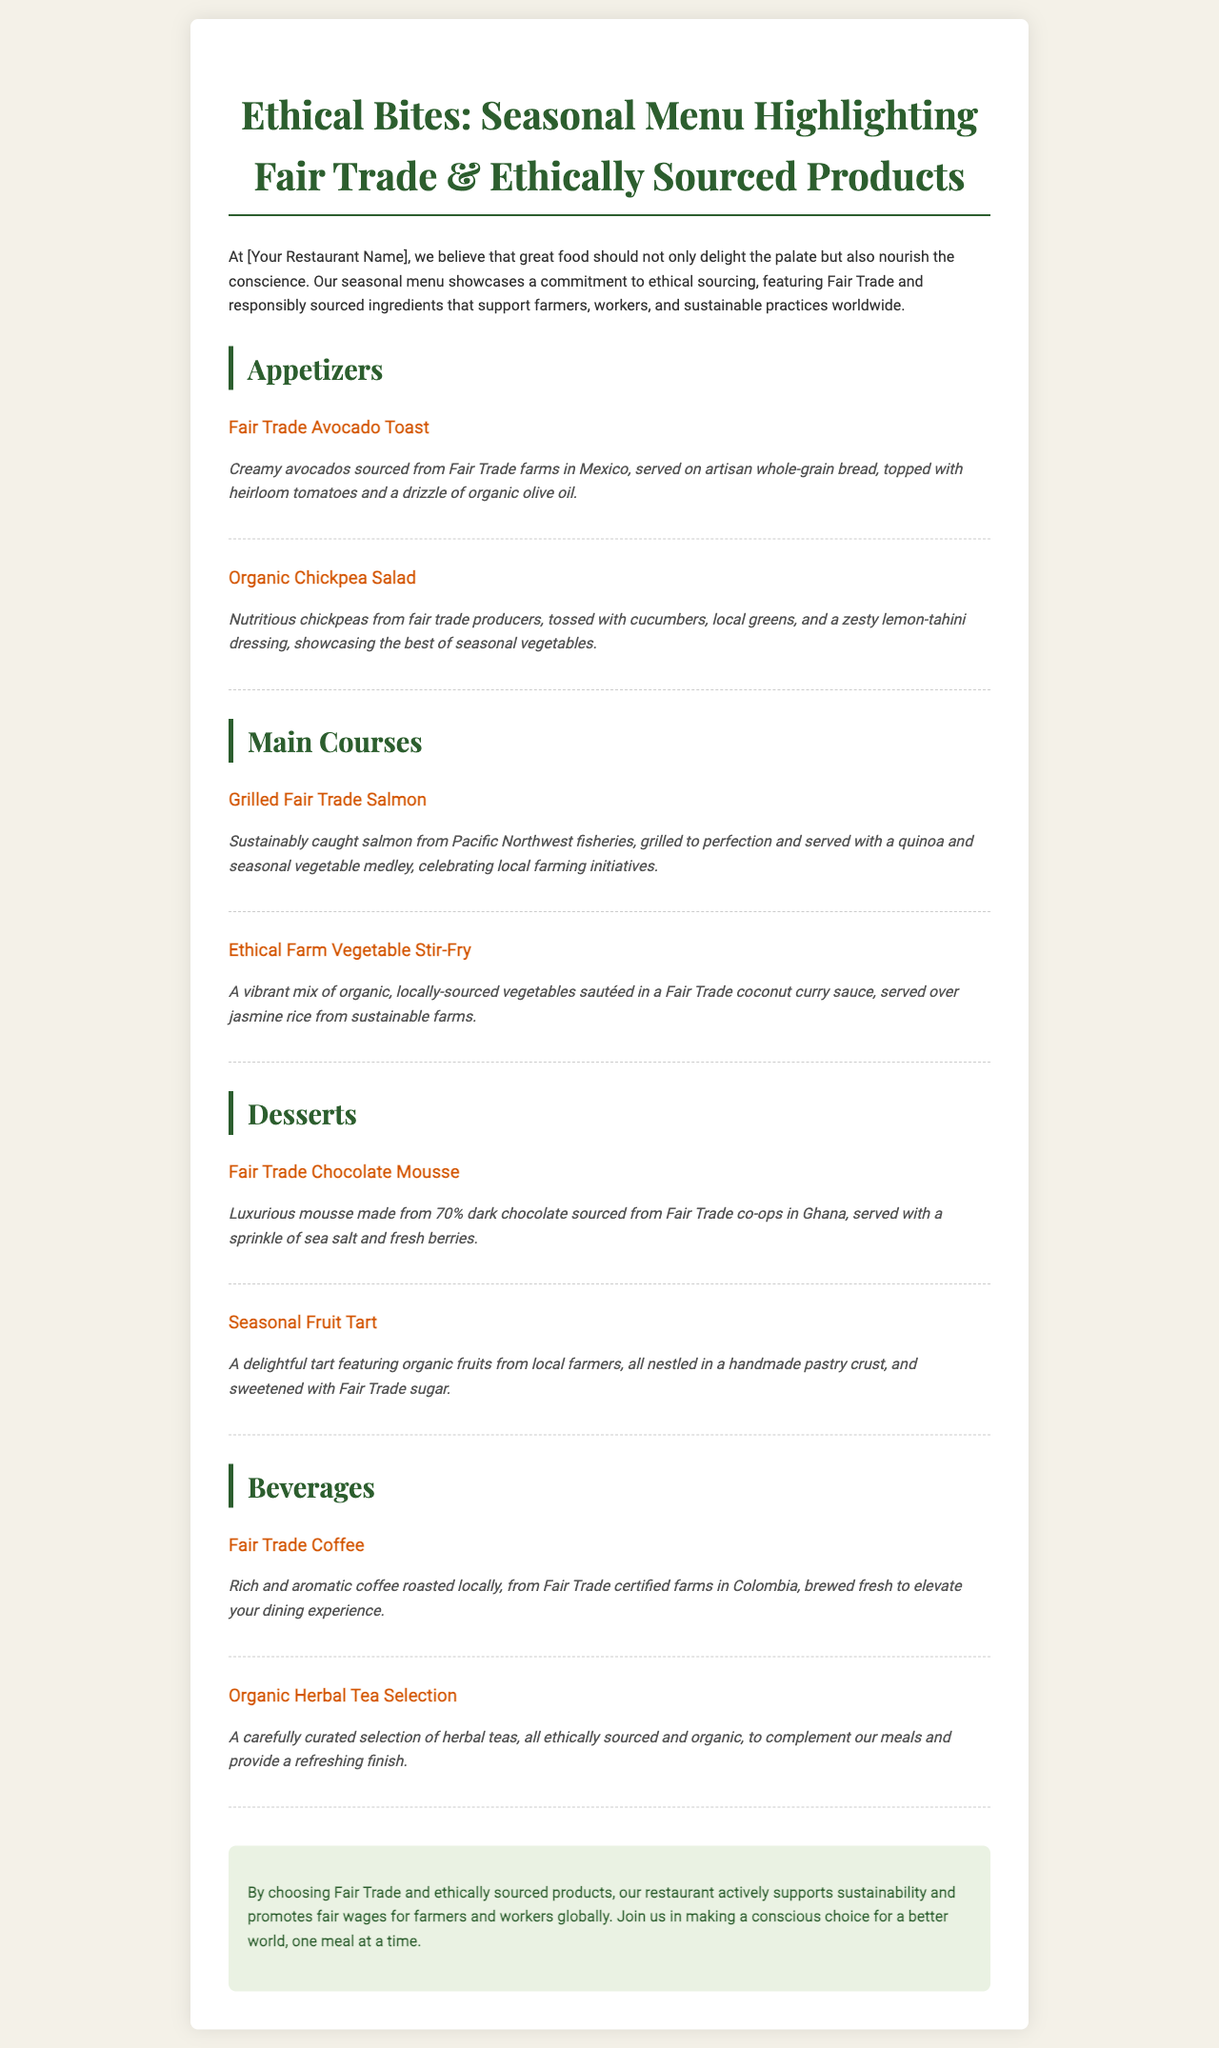what is the name of the menu? The title of the menu is highlighted at the top of the document, which emphasizes its focus on ethical sourcing.
Answer: Ethical Bites: Seasonal Menu Highlighting Fair Trade & Ethically Sourced Products how many appetizers are listed? The document contains a section specifically for appetizers, which includes two distinct items.
Answer: 2 what is the main ingredient in the Fair Trade Chocolate Mousse? The description of the dessert specifically mentions this ingredient as the primary component.
Answer: 70% dark chocolate where does the coffee come from? The document provides information about the origin of the coffee provided in the beverage section.
Answer: Colombia what type of dressing is used in the Organic Chickpea Salad? The description of this salad mentions the specific type of dressing used on the dish.
Answer: lemon-tahini dressing which main course features vegetables sourced locally? The document points out one main course that uses locally sourced vegetables, indicating a commitment to local farming initiatives.
Answer: Ethical Farm Vegetable Stir-Fry what beverage selection is included? The beverage section offers a specific type of selection that is ethically sourced.
Answer: Organic Herbal Tea Selection what promotes fair wages in the restaurant's mission? The commitment section defines the restaurant's goal related to its sourcing practices.
Answer: Fair Trade and ethically sourced products 